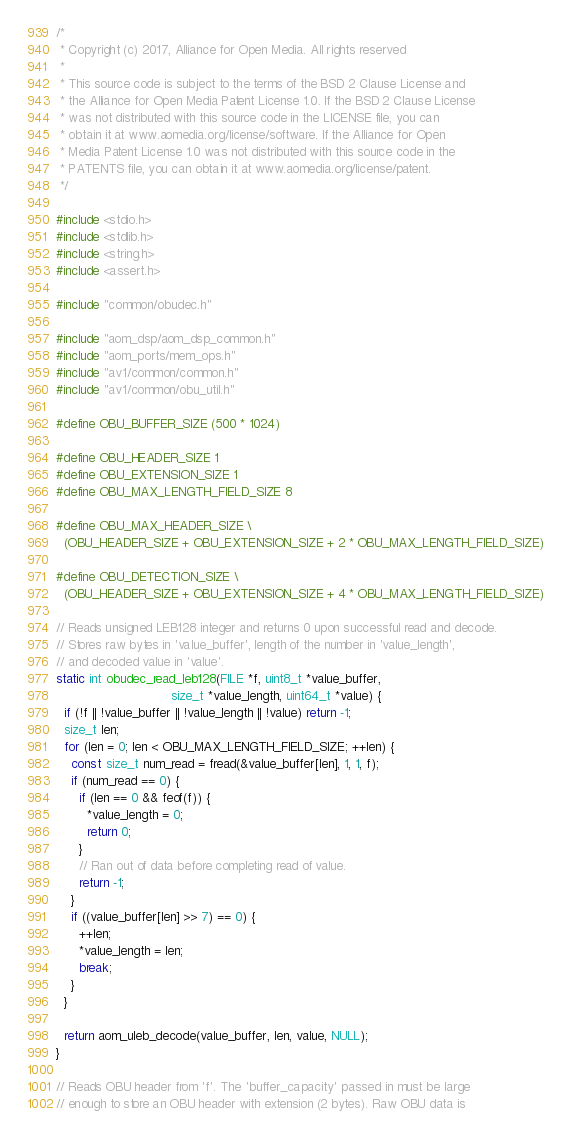Convert code to text. <code><loc_0><loc_0><loc_500><loc_500><_C_>/*
 * Copyright (c) 2017, Alliance for Open Media. All rights reserved
 *
 * This source code is subject to the terms of the BSD 2 Clause License and
 * the Alliance for Open Media Patent License 1.0. If the BSD 2 Clause License
 * was not distributed with this source code in the LICENSE file, you can
 * obtain it at www.aomedia.org/license/software. If the Alliance for Open
 * Media Patent License 1.0 was not distributed with this source code in the
 * PATENTS file, you can obtain it at www.aomedia.org/license/patent.
 */

#include <stdio.h>
#include <stdlib.h>
#include <string.h>
#include <assert.h>

#include "common/obudec.h"

#include "aom_dsp/aom_dsp_common.h"
#include "aom_ports/mem_ops.h"
#include "av1/common/common.h"
#include "av1/common/obu_util.h"

#define OBU_BUFFER_SIZE (500 * 1024)

#define OBU_HEADER_SIZE 1
#define OBU_EXTENSION_SIZE 1
#define OBU_MAX_LENGTH_FIELD_SIZE 8

#define OBU_MAX_HEADER_SIZE \
  (OBU_HEADER_SIZE + OBU_EXTENSION_SIZE + 2 * OBU_MAX_LENGTH_FIELD_SIZE)

#define OBU_DETECTION_SIZE \
  (OBU_HEADER_SIZE + OBU_EXTENSION_SIZE + 4 * OBU_MAX_LENGTH_FIELD_SIZE)

// Reads unsigned LEB128 integer and returns 0 upon successful read and decode.
// Stores raw bytes in 'value_buffer', length of the number in 'value_length',
// and decoded value in 'value'.
static int obudec_read_leb128(FILE *f, uint8_t *value_buffer,
                              size_t *value_length, uint64_t *value) {
  if (!f || !value_buffer || !value_length || !value) return -1;
  size_t len;
  for (len = 0; len < OBU_MAX_LENGTH_FIELD_SIZE; ++len) {
    const size_t num_read = fread(&value_buffer[len], 1, 1, f);
    if (num_read == 0) {
      if (len == 0 && feof(f)) {
        *value_length = 0;
        return 0;
      }
      // Ran out of data before completing read of value.
      return -1;
    }
    if ((value_buffer[len] >> 7) == 0) {
      ++len;
      *value_length = len;
      break;
    }
  }

  return aom_uleb_decode(value_buffer, len, value, NULL);
}

// Reads OBU header from 'f'. The 'buffer_capacity' passed in must be large
// enough to store an OBU header with extension (2 bytes). Raw OBU data is</code> 